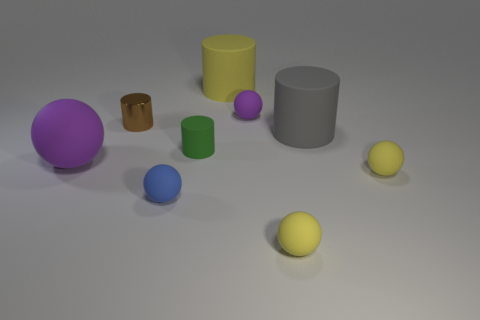Is there anything else that has the same material as the brown cylinder?
Make the answer very short. No. What number of other objects are there of the same size as the brown shiny cylinder?
Keep it short and to the point. 5. Are there any rubber spheres behind the green rubber cylinder?
Give a very brief answer. Yes. Does the big rubber ball have the same color as the tiny ball that is behind the green rubber thing?
Your answer should be compact. Yes. There is a small sphere on the left side of the yellow thing that is behind the purple matte ball to the right of the brown cylinder; what is its color?
Keep it short and to the point. Blue. Is there a large purple thing that has the same shape as the tiny purple thing?
Your answer should be compact. Yes. What is the color of the ball that is the same size as the yellow matte cylinder?
Your answer should be very brief. Purple. What is the purple ball in front of the brown thing made of?
Give a very brief answer. Rubber. There is a big matte thing that is to the left of the yellow rubber cylinder; does it have the same shape as the small matte thing that is behind the green cylinder?
Ensure brevity in your answer.  Yes. Is the number of yellow cylinders that are on the left side of the gray cylinder the same as the number of large yellow rubber blocks?
Your answer should be very brief. No. 